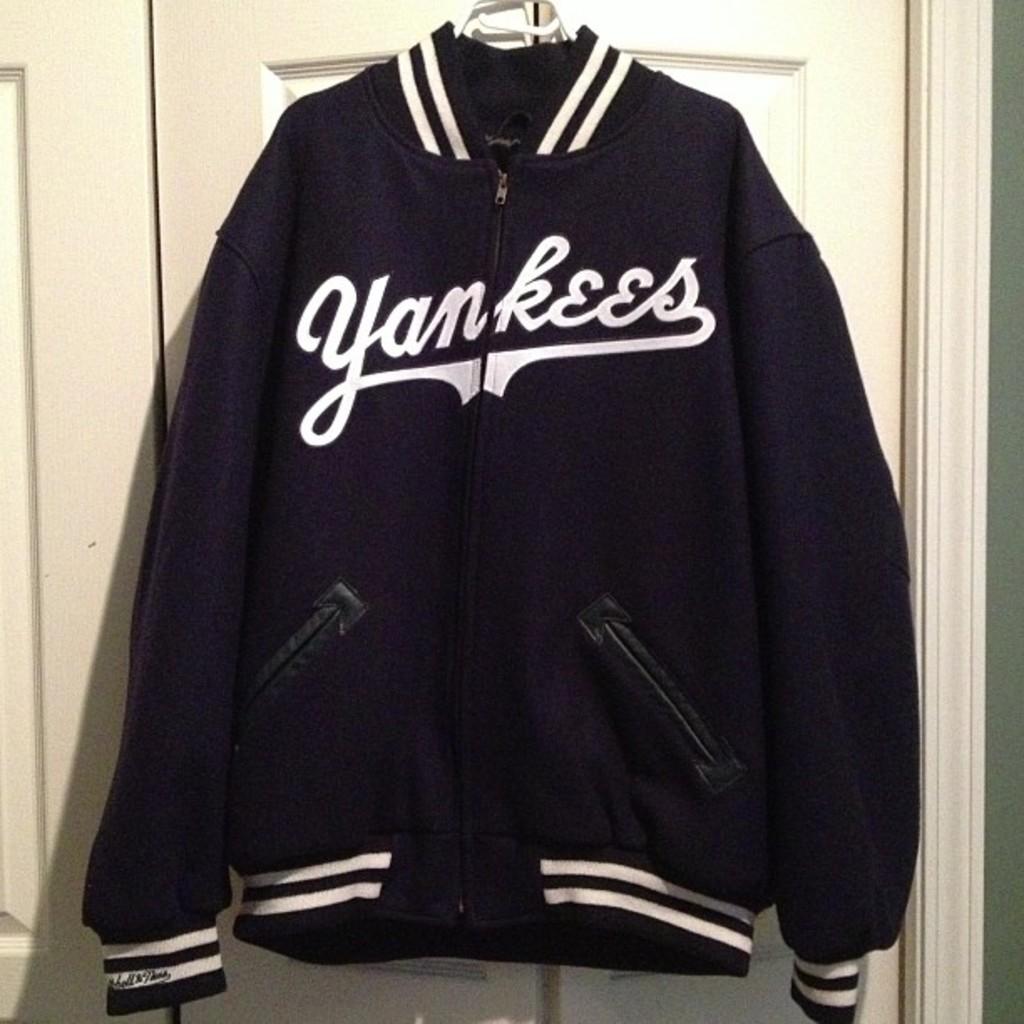What is the name of baseball team on the jacket?
Make the answer very short. Yankees. 